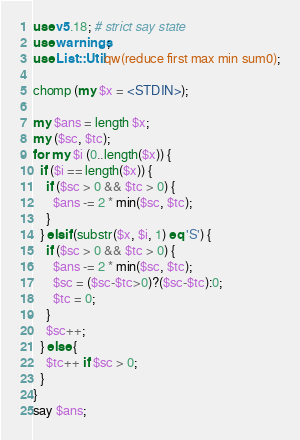Convert code to text. <code><loc_0><loc_0><loc_500><loc_500><_Perl_>use v5.18; # strict say state
use warnings;
use List::Util qw(reduce first max min sum0);

chomp (my $x = <STDIN>);

my $ans = length $x;
my ($sc, $tc);
for my $i (0..length($x)) {
  if ($i == length($x)) {
    if ($sc > 0 && $tc > 0) {
      $ans -= 2 * min($sc, $tc);
    }
  } elsif (substr($x, $i, 1) eq 'S') {
    if ($sc > 0 && $tc > 0) {
      $ans -= 2 * min($sc, $tc);
      $sc = ($sc-$tc>0)?($sc-$tc):0;
      $tc = 0;
    }
    $sc++;
  } else {
    $tc++ if $sc > 0;
  }
}
say $ans;</code> 